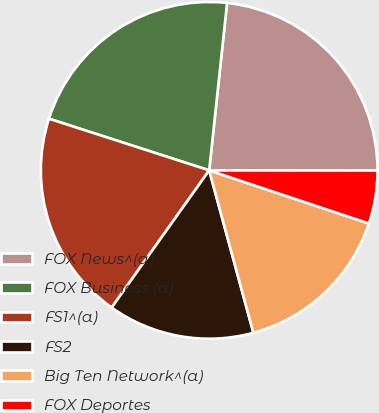Convert chart to OTSL. <chart><loc_0><loc_0><loc_500><loc_500><pie_chart><fcel>FOX News^(a)<fcel>FOX Business (a)<fcel>FS1^(a)<fcel>FS2<fcel>Big Ten Network^(a)<fcel>FOX Deportes<nl><fcel>23.33%<fcel>21.73%<fcel>20.13%<fcel>14.06%<fcel>15.66%<fcel>5.09%<nl></chart> 